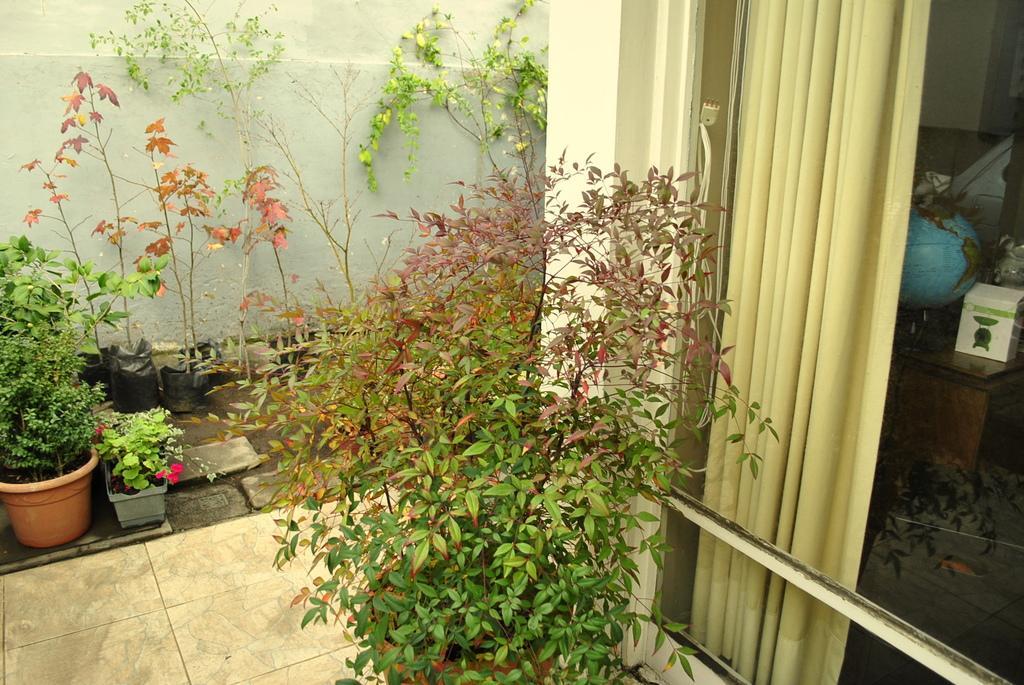Please provide a concise description of this image. In this picture we can see a few flower pots, plants, a curtain, a globe, a box and other objects on the wooden table. We can see other objects. 